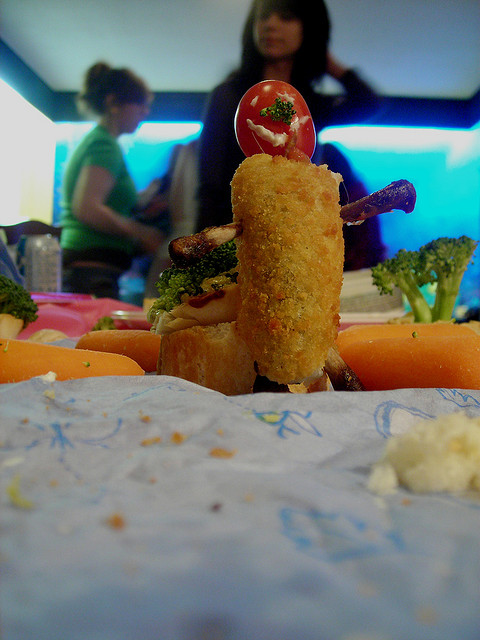<image>Is this a banquet? I am not sure if this is a banquet. It could be either yes or no. Is this a banquet? I am not sure if this is a banquet. It can be both a banquet or not. 